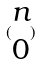Convert formula to latex. <formula><loc_0><loc_0><loc_500><loc_500>( \begin{matrix} n \\ 0 \end{matrix} )</formula> 